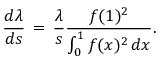<formula> <loc_0><loc_0><loc_500><loc_500>\frac { d \lambda } { d s } \, = \, \frac { \lambda } { s } \frac { f ( 1 ) ^ { 2 } } { \int _ { 0 } ^ { 1 } f ( x ) ^ { 2 } \, d x } .</formula> 